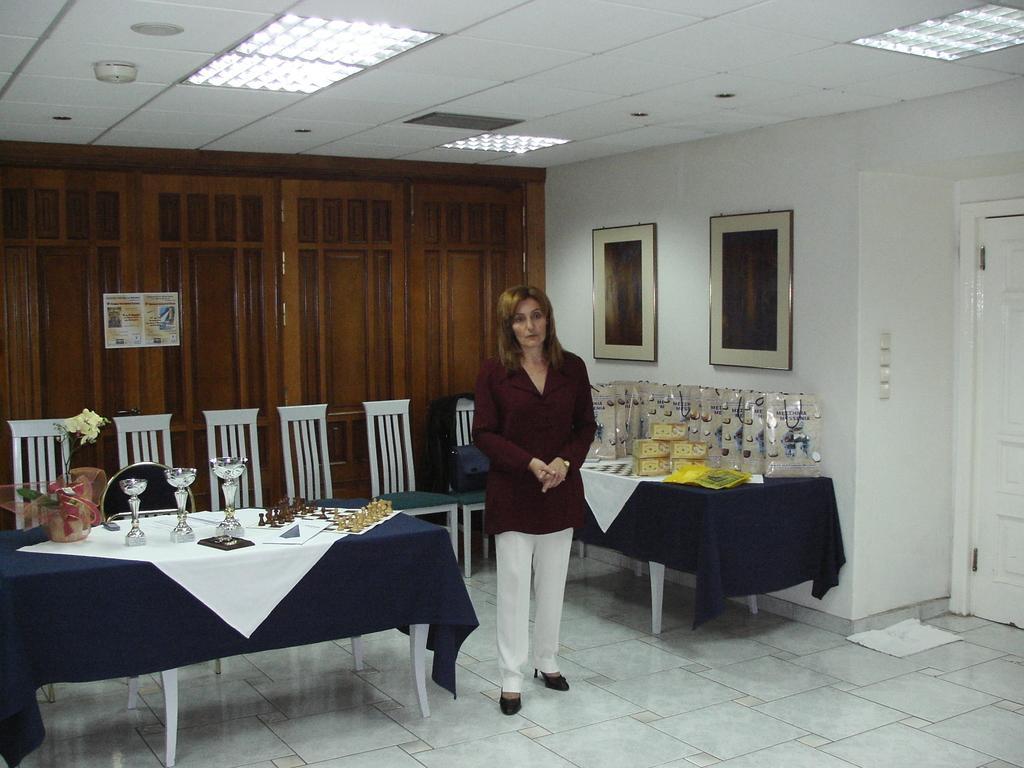In one or two sentences, can you explain what this image depicts? In this picture, there is a floor which is white color, there are some tables which are covered by blue color clothes, on that table there are some white objects, in the middle there is a woman she is standing, in the right side there are some color bags kept and there are some yellow color box kept, in the background there are some brown color doors, in the right side there is a white color wall on that there are some black color pictures, there is a white color roof. 